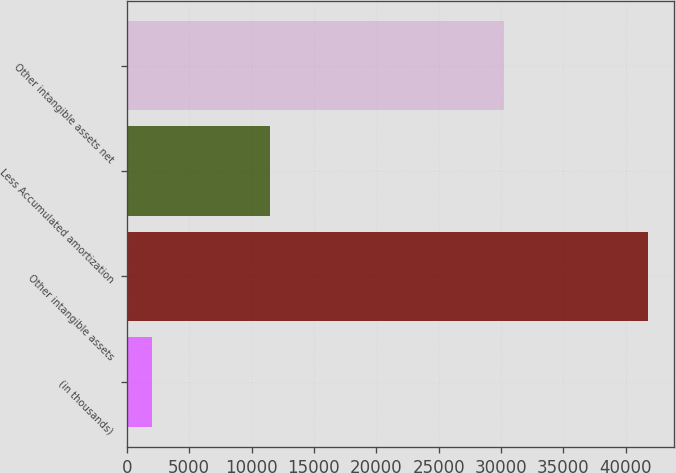<chart> <loc_0><loc_0><loc_500><loc_500><bar_chart><fcel>(in thousands)<fcel>Other intangible assets<fcel>Less Accumulated amortization<fcel>Other intangible assets net<nl><fcel>2010<fcel>41759<fcel>11494<fcel>30265<nl></chart> 